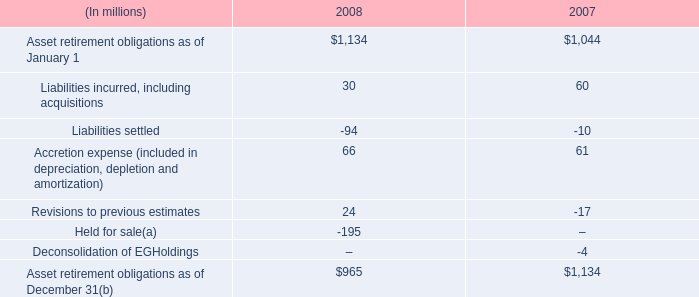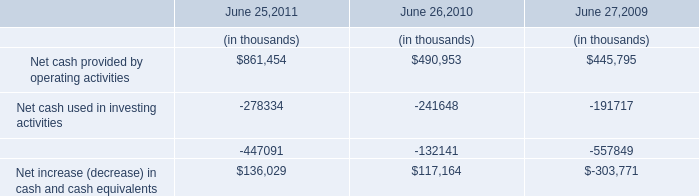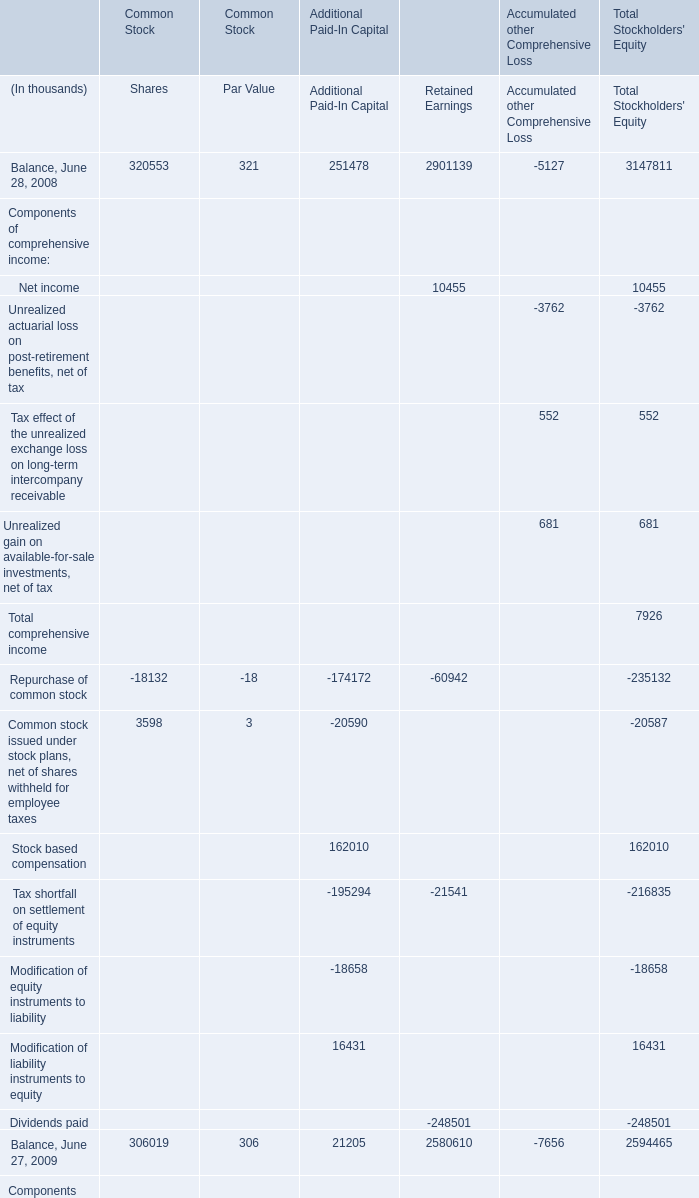What is the difference between the greatest Retained Earnings in 2008 and 2009？ (in thousand) 
Computations: (2901139 - 2580610)
Answer: 320529.0. 